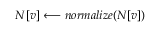<formula> <loc_0><loc_0><loc_500><loc_500>N [ v ] \longleftarrow n o r m a l i z e ( N [ v ] )</formula> 